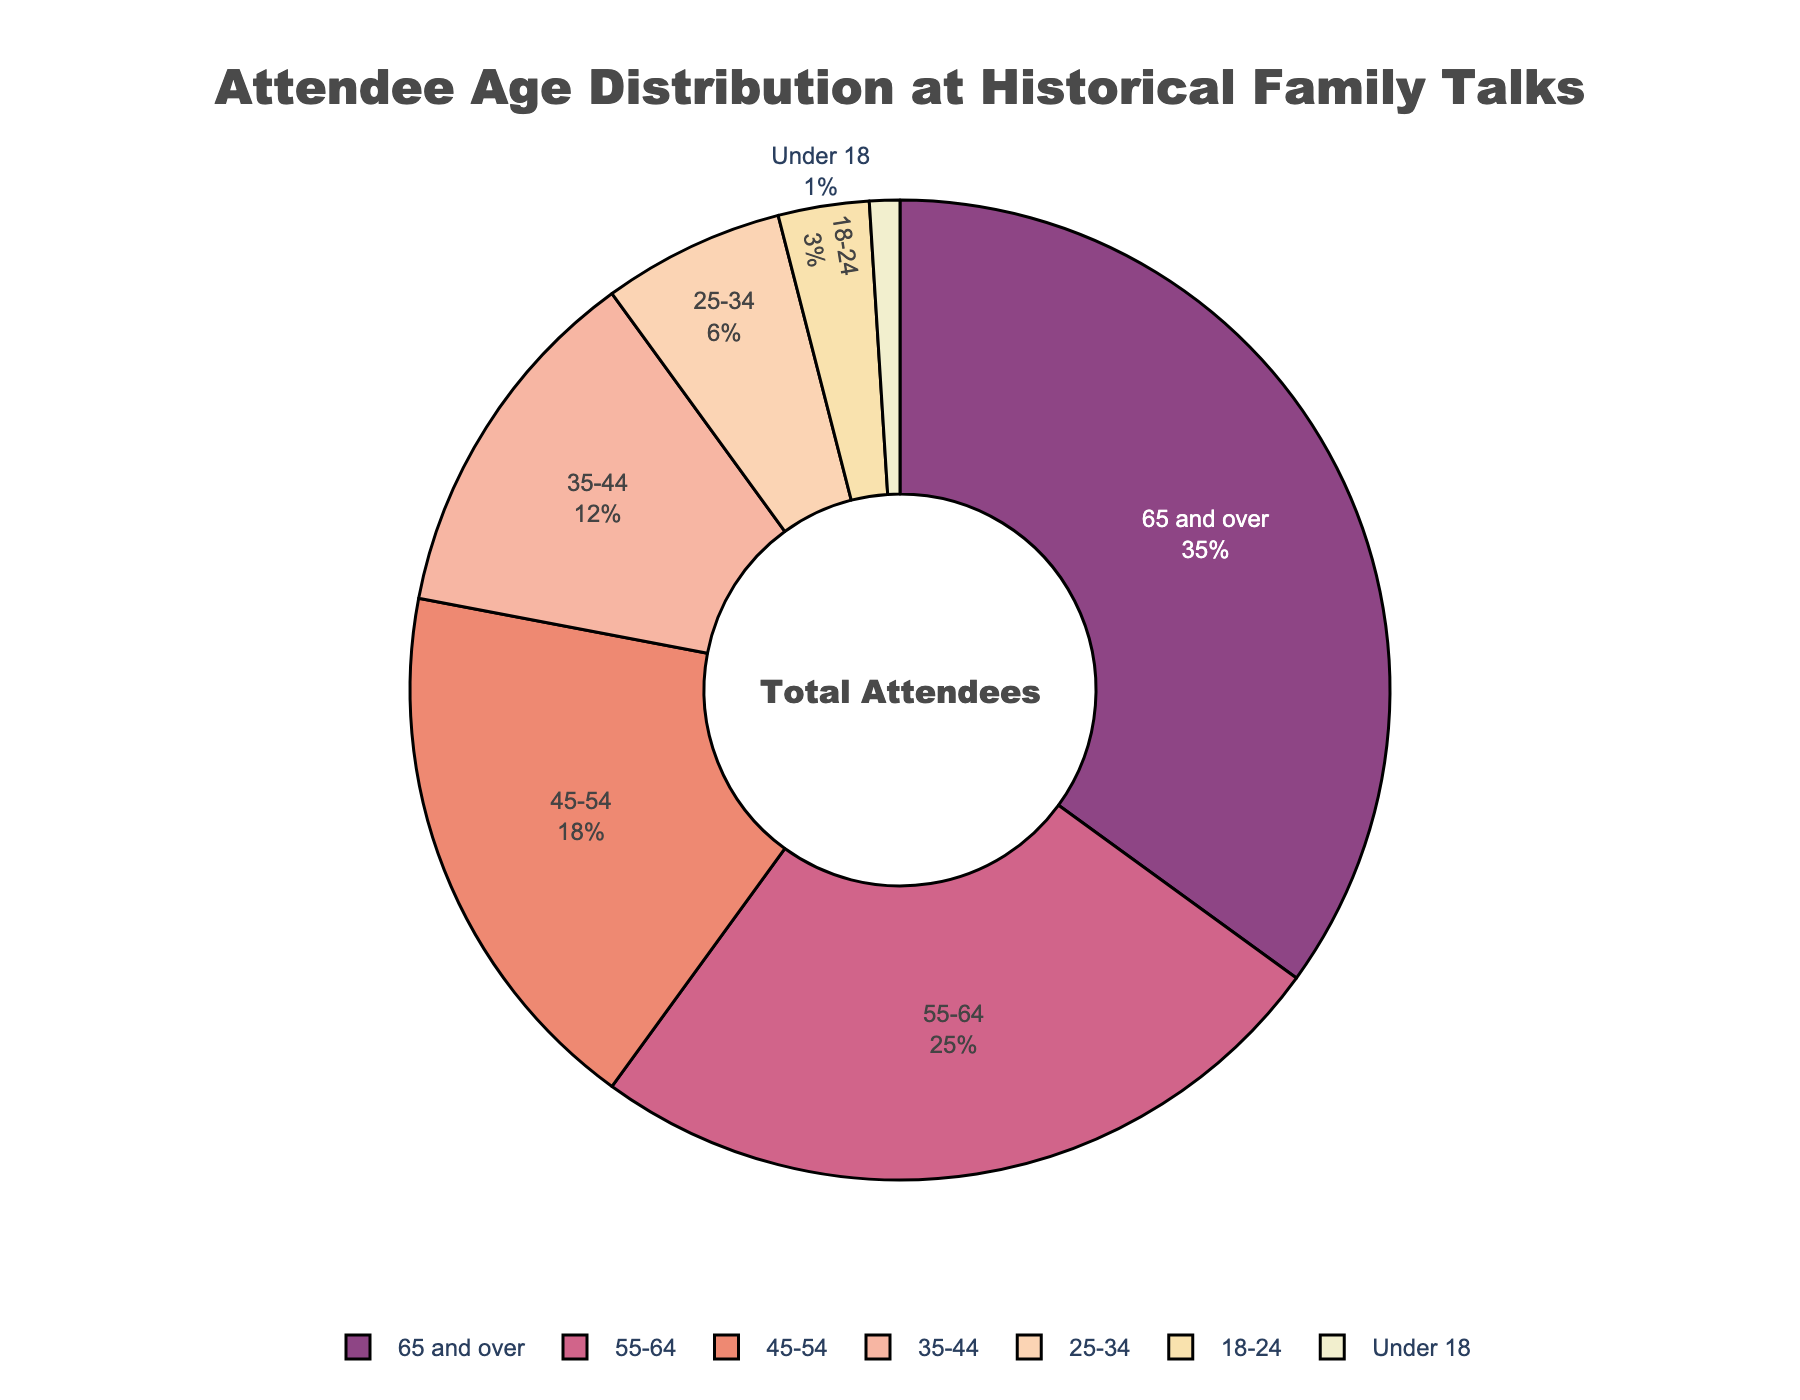What's the largest age group among the attendees? By visually examining the pie chart, we see the section with the largest percentage is labeled "65 and over", which has 35%.
Answer: 65 and over Which age group has the smallest representation? The smallest section on the pie chart corresponds to "Under 18", which makes up 1% of the attendees.
Answer: Under 18 What is the total percentage of attendees aged 55 and over? Add the percentages of the age groups "55-64" and "65 and over". The percentage for "55-64" is 25% and for "65 and over" is 35%. Adding them together gives 25% + 35% = 60%.
Answer: 60% How does the percentage of attendees aged 25-34 compare to those aged 18-24? From the pie chart, attendees aged 25-34 make up 6% and those aged 18-24 make up 3%. Therefore, attendees aged 25-34 have a greater representation, specifically twice as much.
Answer: 25-34 is twice as much as 18-24 What percentage of the audience is under 45 years old? Add the percentages of the age groups "Under 18", "18-24", "25-34", and "35-44". The percentages are 1%, 3%, 6%, and 12%, respectively. Adding them together gives 1% + 3% + 6% + 12% = 22%.
Answer: 22% Which age group is represented by the peach-colored section in the pie chart? The peach-colored section corresponds to the "35-44" age group, which makes up 12% of the attendees. We can identify this by visually matching the color coding in the pie chart's legend.
Answer: 35-44 What is the combined percentage of attendees in the 45-54 and 35-44 age groups? Add the percentages of the age groups "45-54" and "35-44". The percentage for "45-54" is 18% and for "35-44" is 12%. Adding them together gives 18% + 12% = 30%.
Answer: 30% If we combine the percentage of the youngest two age groups, how does that compare to the percentage of the 55-64 age group? The youngest two age groups are "Under 18" (1%) and "18-24" (3%). Combining these gives 1% + 3% = 4%. The percentage for the "55-64" age group is 25%. Thus, the combined percentage of the youngest two age groups (4%) is significantly smaller than that of the "55-64" age group (25%).
Answer: Smaller What percentage of attendees are aged 25-54? Add the percentages of the age groups "25-34", "35-44", and "45-54". The percentages are 6%, 12%, and 18%, respectively. Adding them together gives 6% + 12% + 18% = 36%.
Answer: 36% 